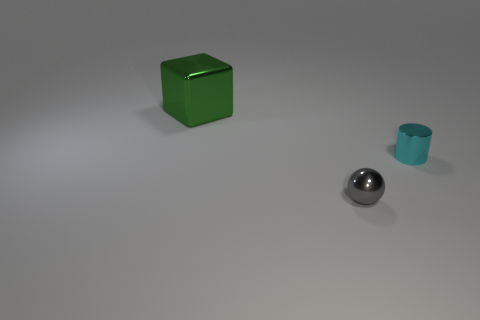Add 1 green things. How many objects exist? 4 Subtract 1 cylinders. How many cylinders are left? 0 Add 3 cyan objects. How many cyan objects are left? 4 Add 1 metal spheres. How many metal spheres exist? 2 Subtract 0 purple spheres. How many objects are left? 3 Subtract all spheres. How many objects are left? 2 Subtract all cyan metallic cylinders. Subtract all tiny cyan metal objects. How many objects are left? 1 